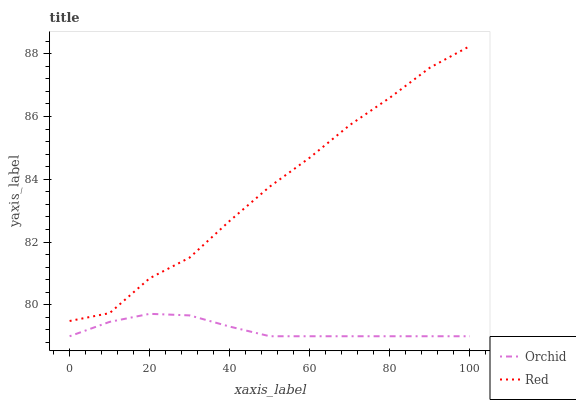Does Orchid have the minimum area under the curve?
Answer yes or no. Yes. Does Red have the maximum area under the curve?
Answer yes or no. Yes. Does Orchid have the maximum area under the curve?
Answer yes or no. No. Is Orchid the smoothest?
Answer yes or no. Yes. Is Red the roughest?
Answer yes or no. Yes. Is Orchid the roughest?
Answer yes or no. No. Does Orchid have the lowest value?
Answer yes or no. Yes. Does Red have the highest value?
Answer yes or no. Yes. Does Orchid have the highest value?
Answer yes or no. No. Is Orchid less than Red?
Answer yes or no. Yes. Is Red greater than Orchid?
Answer yes or no. Yes. Does Orchid intersect Red?
Answer yes or no. No. 